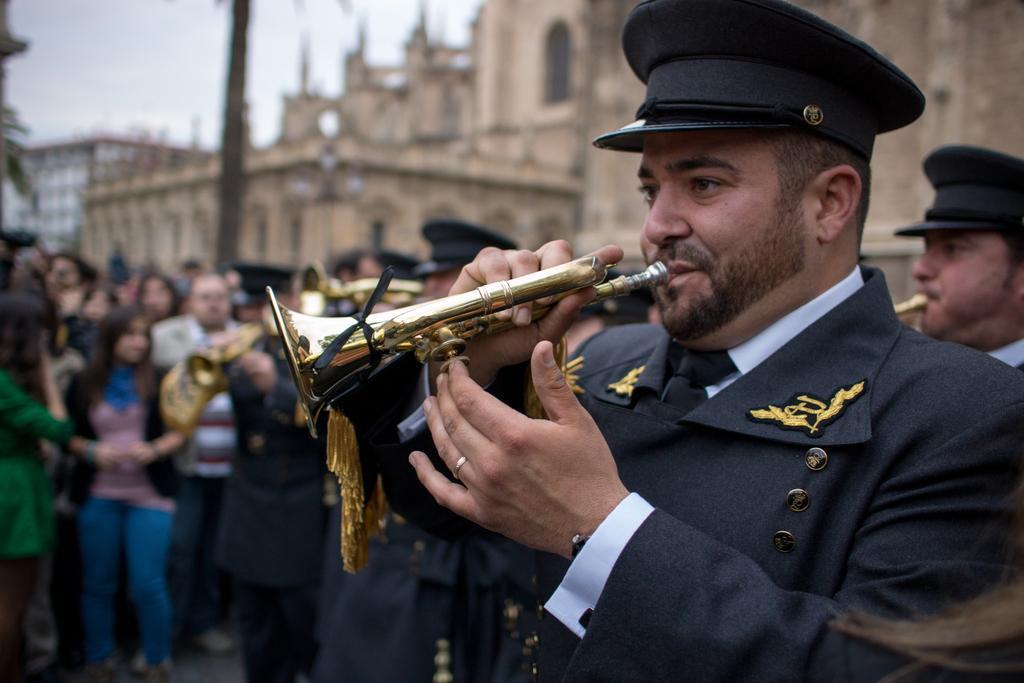Could you give a brief overview of what you see in this image? In this picture we can see there is a group of people playing the brass instruments. Behind the people there are groups of people, buildings and a sky. 